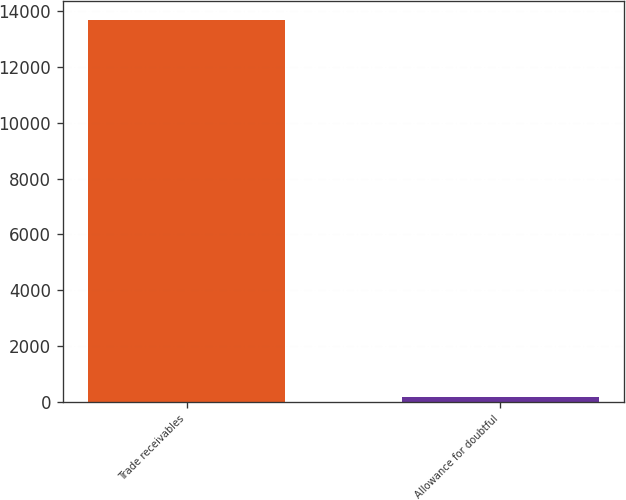Convert chart. <chart><loc_0><loc_0><loc_500><loc_500><bar_chart><fcel>Trade receivables<fcel>Allowance for doubtful<nl><fcel>13674<fcel>158<nl></chart> 